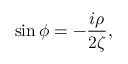<formula> <loc_0><loc_0><loc_500><loc_500>\sin \phi = - \frac { i \rho } { 2 \zeta } ,</formula> 